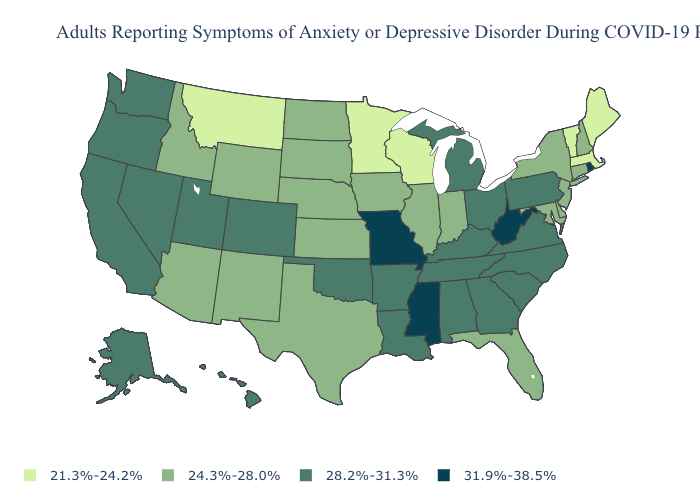What is the highest value in the Northeast ?
Quick response, please. 31.9%-38.5%. Does the map have missing data?
Answer briefly. No. Which states have the lowest value in the USA?
Concise answer only. Maine, Massachusetts, Minnesota, Montana, Vermont, Wisconsin. What is the value of Virginia?
Quick response, please. 28.2%-31.3%. Does Oklahoma have the lowest value in the USA?
Quick response, please. No. Is the legend a continuous bar?
Quick response, please. No. Among the states that border Louisiana , does Mississippi have the lowest value?
Answer briefly. No. Name the states that have a value in the range 24.3%-28.0%?
Give a very brief answer. Arizona, Connecticut, Delaware, Florida, Idaho, Illinois, Indiana, Iowa, Kansas, Maryland, Nebraska, New Hampshire, New Jersey, New Mexico, New York, North Dakota, South Dakota, Texas, Wyoming. What is the value of North Dakota?
Answer briefly. 24.3%-28.0%. What is the value of Oklahoma?
Answer briefly. 28.2%-31.3%. Does Rhode Island have the highest value in the Northeast?
Give a very brief answer. Yes. Name the states that have a value in the range 24.3%-28.0%?
Write a very short answer. Arizona, Connecticut, Delaware, Florida, Idaho, Illinois, Indiana, Iowa, Kansas, Maryland, Nebraska, New Hampshire, New Jersey, New Mexico, New York, North Dakota, South Dakota, Texas, Wyoming. Name the states that have a value in the range 28.2%-31.3%?
Concise answer only. Alabama, Alaska, Arkansas, California, Colorado, Georgia, Hawaii, Kentucky, Louisiana, Michigan, Nevada, North Carolina, Ohio, Oklahoma, Oregon, Pennsylvania, South Carolina, Tennessee, Utah, Virginia, Washington. Name the states that have a value in the range 31.9%-38.5%?
Keep it brief. Mississippi, Missouri, Rhode Island, West Virginia. Name the states that have a value in the range 28.2%-31.3%?
Quick response, please. Alabama, Alaska, Arkansas, California, Colorado, Georgia, Hawaii, Kentucky, Louisiana, Michigan, Nevada, North Carolina, Ohio, Oklahoma, Oregon, Pennsylvania, South Carolina, Tennessee, Utah, Virginia, Washington. 